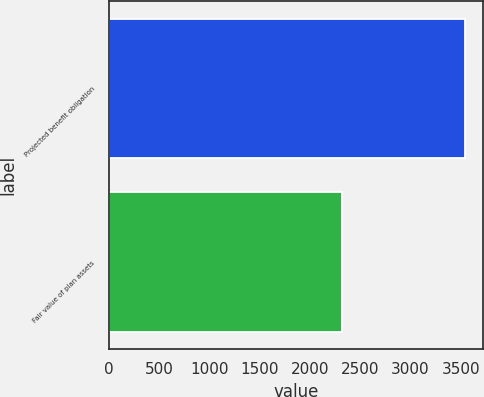<chart> <loc_0><loc_0><loc_500><loc_500><bar_chart><fcel>Projected benefit obligation<fcel>Fair value of plan assets<nl><fcel>3540<fcel>2314<nl></chart> 